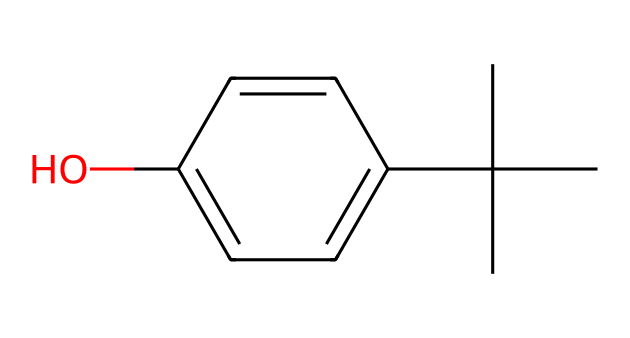What is the name of this chemical? The chemical represented by the given SMILES is Bisphenol A (BPA) due to the presence of the phenol rings and the tert-butyl group attached, confirming its classification.
Answer: Bisphenol A How many carbon atoms are in this structure? By analyzing the SMILES notation, we count the 'C's present, including those in the tert-butyl group and the aromatic rings, resulting in a total of 15 carbon atoms.
Answer: 15 What functional group is present in this molecule? Upon examining the structure, the hydroxyl group (-OH) is evident, which is characteristic of phenolic compounds, confirming the presence of a phenolic functional group.
Answer: hydroxyl Does this chemical contain any double bonds? Inspecting the SMILES reveals no double bond indicators (no '=' symbols), indicating that this molecule has only single bonds between the carbon atoms and other groups.
Answer: no What is the molecular formula of this chemical? By combining the counted atoms from the structure—15 carbons, 16 hydrogens, and 1 oxygen—the empirical data sums up to the molecular formula C15H16O.
Answer: C15H16O Can this chemical form hydrogen bonds? Given the presence of the hydroxyl group (-OH), which can interact with other electron-rich atoms or groups, this molecule can indeed form hydrogen bonds due to the polar nature of the hydroxyl.
Answer: yes How is this molecule likely to dissolve in water? The presence of the polar hydroxyl group suggests that the molecule can interact favorably with water, allowing it to become partially soluble due to hydrogen bonding attractions with water molecules.
Answer: partially soluble 